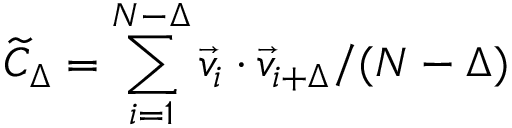Convert formula to latex. <formula><loc_0><loc_0><loc_500><loc_500>\widetilde { C } _ { \Delta } = \sum _ { i = 1 } ^ { N - \Delta } \vec { v } _ { i } \cdot \vec { v } _ { i + \Delta } / ( N - \Delta )</formula> 